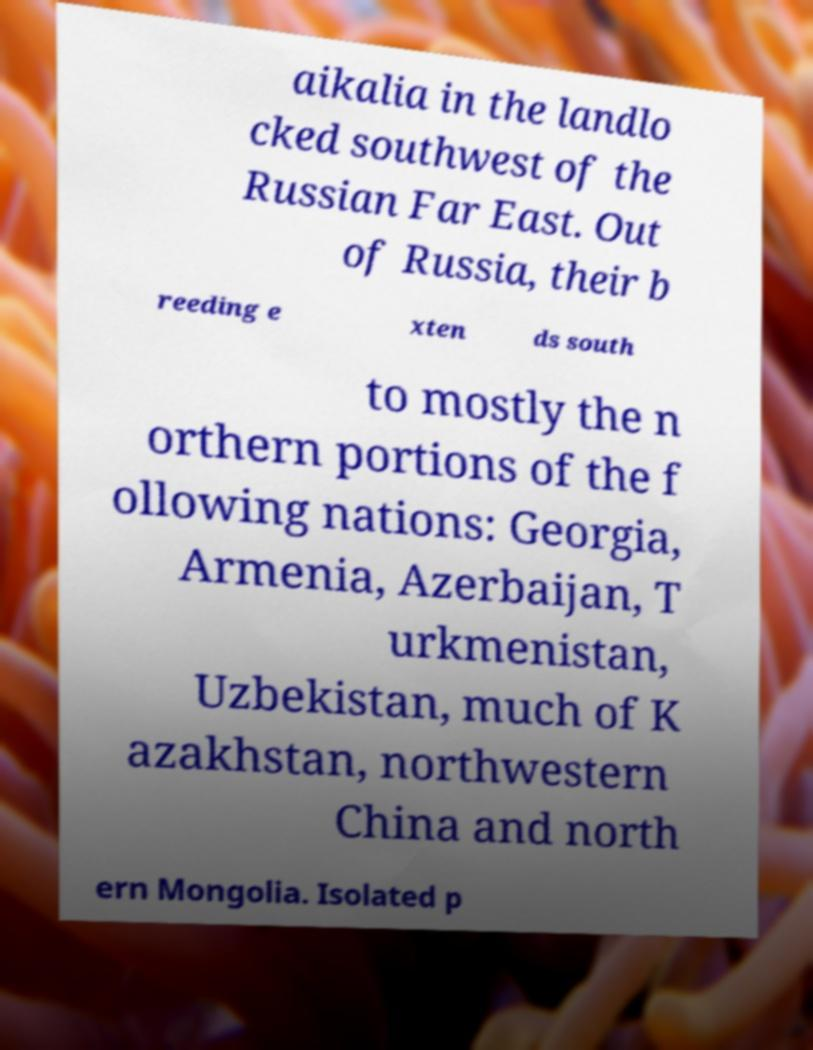Please identify and transcribe the text found in this image. aikalia in the landlo cked southwest of the Russian Far East. Out of Russia, their b reeding e xten ds south to mostly the n orthern portions of the f ollowing nations: Georgia, Armenia, Azerbaijan, T urkmenistan, Uzbekistan, much of K azakhstan, northwestern China and north ern Mongolia. Isolated p 